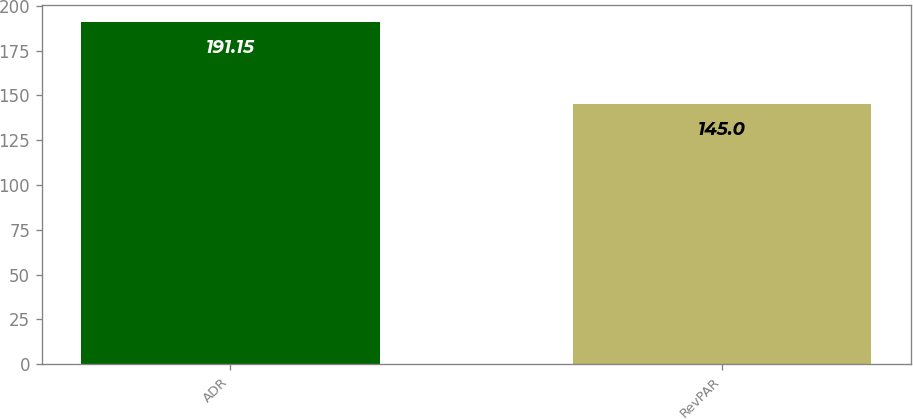Convert chart to OTSL. <chart><loc_0><loc_0><loc_500><loc_500><bar_chart><fcel>ADR<fcel>RevPAR<nl><fcel>191.15<fcel>145<nl></chart> 